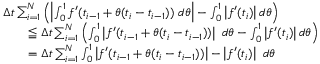Convert formula to latex. <formula><loc_0><loc_0><loc_500><loc_500>{ \begin{array} { r l } & { \Delta t \sum _ { i = 1 } ^ { N } \left ( \left | \int _ { 0 } ^ { 1 } f ^ { \prime } ( t _ { i - 1 } + \theta ( t _ { i } - t _ { i - 1 } ) ) \ d \theta \right | - \int _ { 0 } ^ { 1 } \left | f ^ { \prime } ( t _ { i } ) \right | d \theta \right ) } \\ & { \quad \leqq \Delta t \sum _ { i = 1 } ^ { N } \left ( \int _ { 0 } ^ { 1 } \left | f ^ { \prime } ( t _ { i - 1 } + \theta ( t _ { i } - t _ { i - 1 } ) ) \right | \ d \theta - \int _ { 0 } ^ { 1 } \left | f ^ { \prime } ( t _ { i } ) \right | d \theta \right ) } \\ & { \quad = \Delta t \sum _ { i = 1 } ^ { N } \int _ { 0 } ^ { 1 } \left | f ^ { \prime } ( t _ { i - 1 } + \theta ( t _ { i } - t _ { i - 1 } ) ) \right | - \left | f ^ { \prime } ( t _ { i } ) \right | \ d \theta } \end{array} }</formula> 